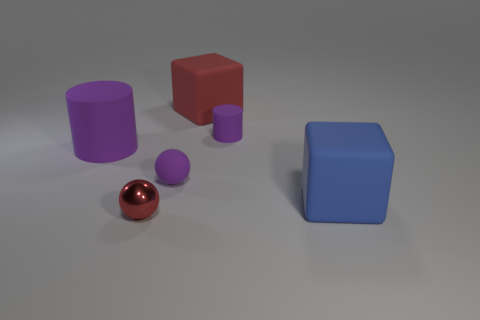What size is the red cube?
Ensure brevity in your answer.  Large. There is a small ball that is the same material as the tiny cylinder; what is its color?
Your answer should be very brief. Purple. What number of tiny purple objects are the same material as the big purple cylinder?
Ensure brevity in your answer.  2. How many things are either blue matte objects or purple objects that are to the right of the red metallic thing?
Your response must be concise. 3. Is the ball that is behind the small red sphere made of the same material as the large red block?
Provide a succinct answer. Yes. What color is the matte cylinder that is the same size as the blue rubber cube?
Make the answer very short. Purple. Is there a small rubber thing of the same shape as the red metallic thing?
Offer a terse response. Yes. What is the color of the large block in front of the rubber cube on the left side of the matte block that is in front of the red block?
Ensure brevity in your answer.  Blue. What number of rubber things are red spheres or big blue cylinders?
Provide a succinct answer. 0. Is the number of large purple rubber things that are on the right side of the purple ball greater than the number of rubber cylinders that are right of the big purple rubber cylinder?
Make the answer very short. No. 